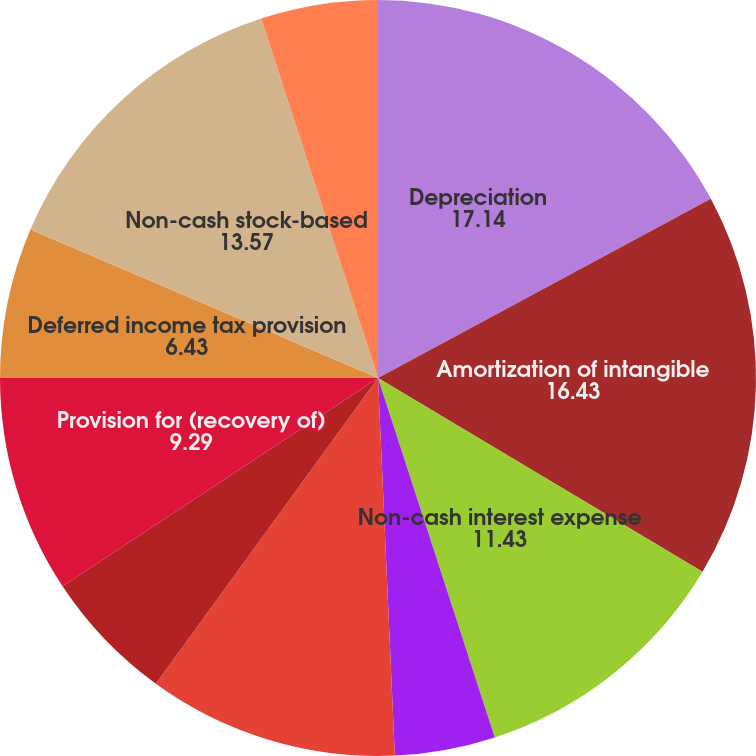Convert chart to OTSL. <chart><loc_0><loc_0><loc_500><loc_500><pie_chart><fcel>Depreciation<fcel>Amortization of intangible<fcel>Non-cash interest expense<fcel>Amortization of debt issuance<fcel>Amortization of deferred<fcel>Loss on sale of property and<fcel>Provision for (recovery of)<fcel>Deferred income tax provision<fcel>Non-cash stock-based<fcel>Tax impact of stock-based<nl><fcel>17.14%<fcel>16.43%<fcel>11.43%<fcel>4.29%<fcel>10.71%<fcel>5.71%<fcel>9.29%<fcel>6.43%<fcel>13.57%<fcel>5.0%<nl></chart> 